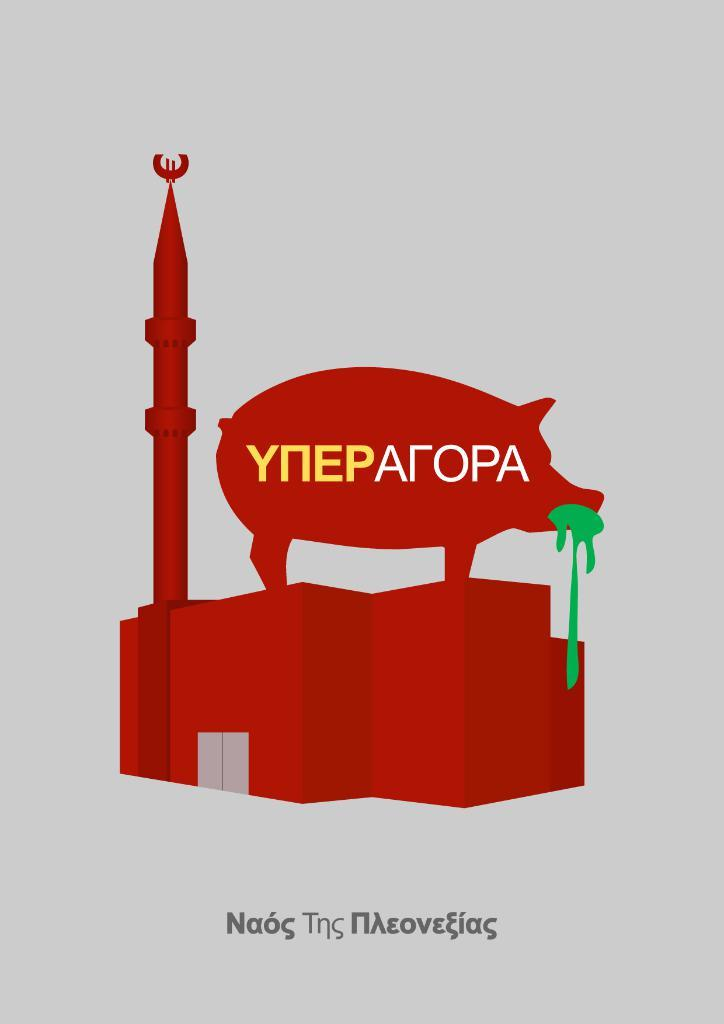<image>
Share a concise interpretation of the image provided. a pig on building with some foreign letter like ynepatopa 